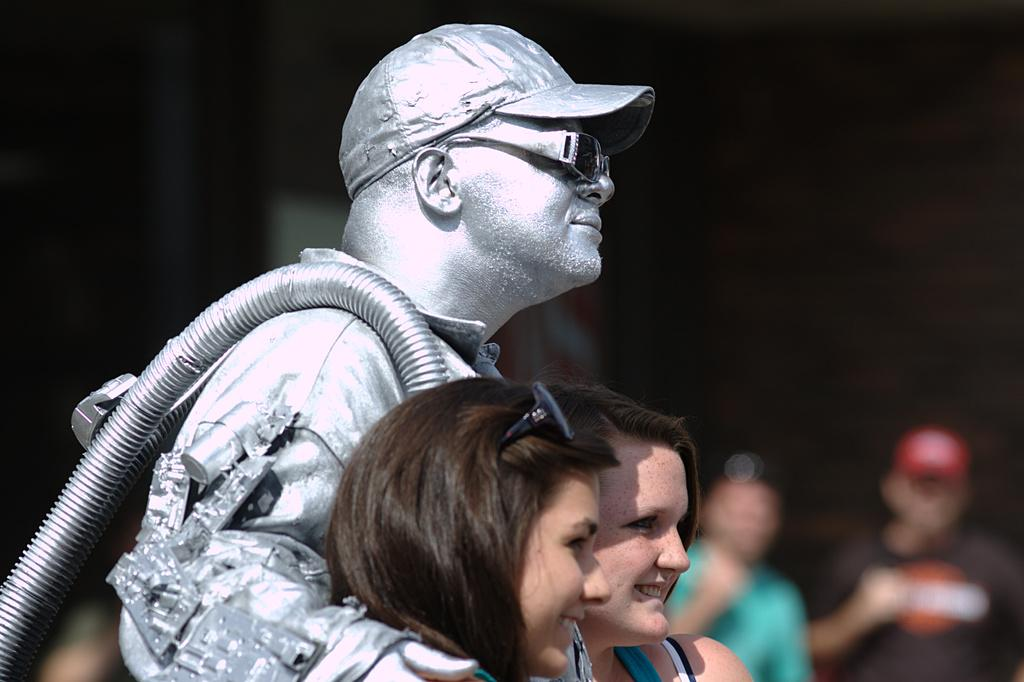What is happening in the image? There are people standing in the image. Can you describe any specific details about the people? There is a painting on a man in the image. What else can be seen in the image besides the people? There is a pipe visible in the image. What color is the boundary between the people and the painting? There is no boundary between the people and the painting mentioned in the image, and therefore no color can be assigned to it. 